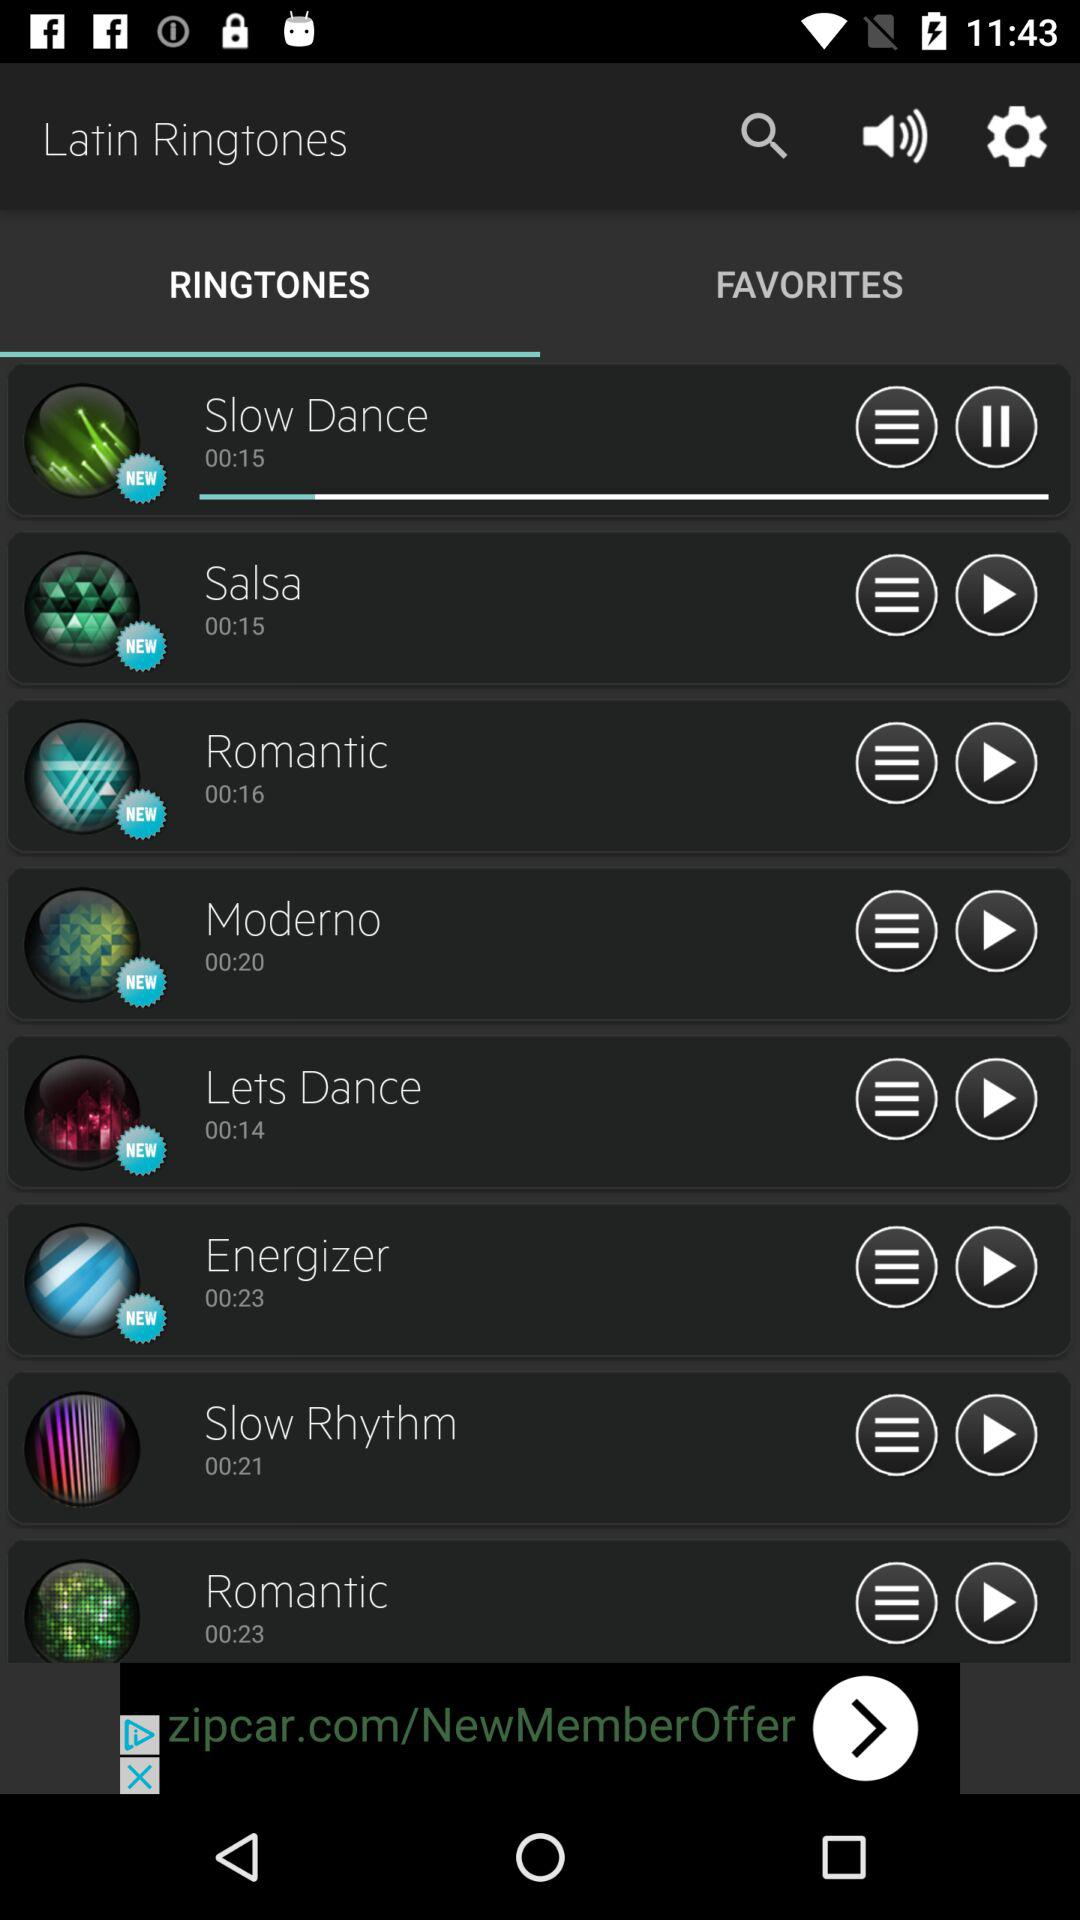What are the different ringtones? The different ringtones are : "Slow Dance", "Salsa", "Romantic", "Moderno", "Lets Dance", "Energizer", "Slow Rhythm", and "Romantic". 